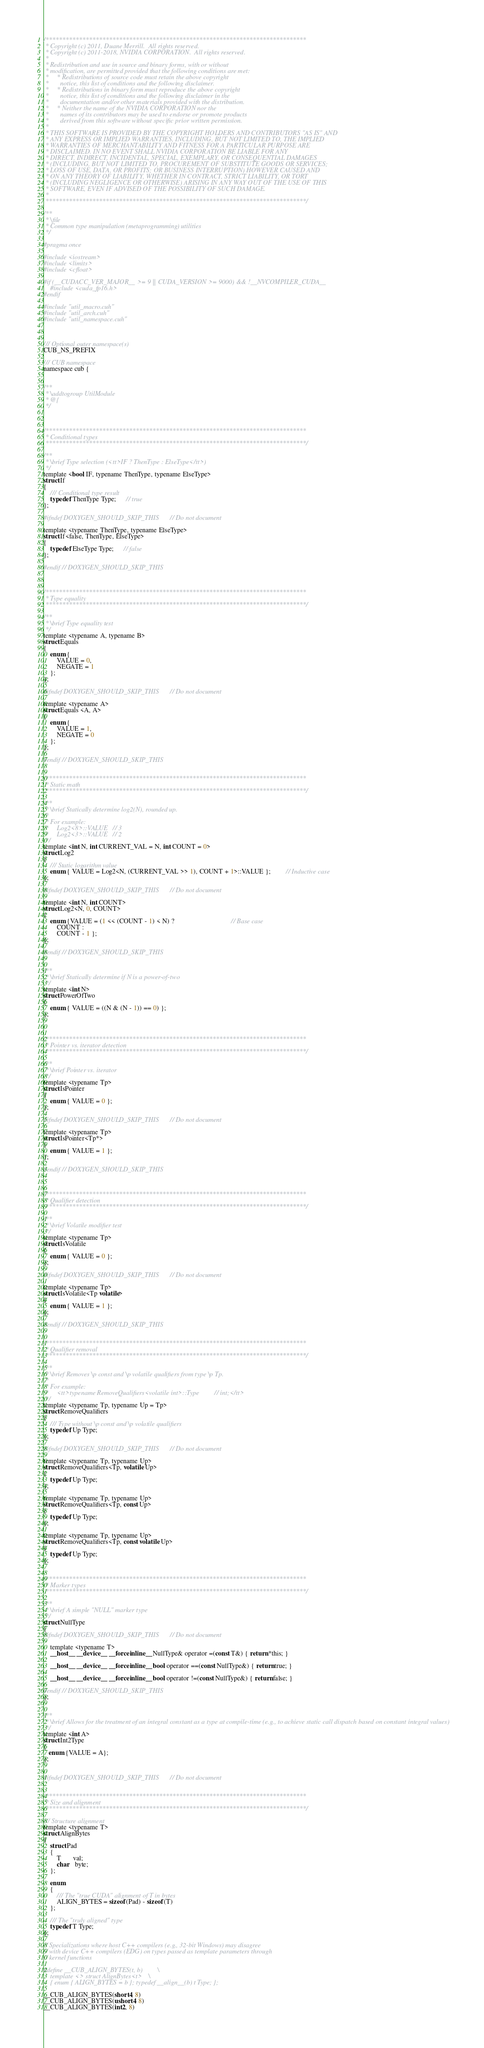<code> <loc_0><loc_0><loc_500><loc_500><_Cuda_>/******************************************************************************
 * Copyright (c) 2011, Duane Merrill.  All rights reserved.
 * Copyright (c) 2011-2018, NVIDIA CORPORATION.  All rights reserved.
 * 
 * Redistribution and use in source and binary forms, with or without
 * modification, are permitted provided that the following conditions are met:
 *     * Redistributions of source code must retain the above copyright
 *       notice, this list of conditions and the following disclaimer.
 *     * Redistributions in binary form must reproduce the above copyright
 *       notice, this list of conditions and the following disclaimer in the
 *       documentation and/or other materials provided with the distribution.
 *     * Neither the name of the NVIDIA CORPORATION nor the
 *       names of its contributors may be used to endorse or promote products
 *       derived from this software without specific prior written permission.
 * 
 * THIS SOFTWARE IS PROVIDED BY THE COPYRIGHT HOLDERS AND CONTRIBUTORS "AS IS" AND
 * ANY EXPRESS OR IMPLIED WARRANTIES, INCLUDING, BUT NOT LIMITED TO, THE IMPLIED
 * WARRANTIES OF MERCHANTABILITY AND FITNESS FOR A PARTICULAR PURPOSE ARE
 * DISCLAIMED. IN NO EVENT SHALL NVIDIA CORPORATION BE LIABLE FOR ANY
 * DIRECT, INDIRECT, INCIDENTAL, SPECIAL, EXEMPLARY, OR CONSEQUENTIAL DAMAGES
 * (INCLUDING, BUT NOT LIMITED TO, PROCUREMENT OF SUBSTITUTE GOODS OR SERVICES;
 * LOSS OF USE, DATA, OR PROFITS; OR BUSINESS INTERRUPTION) HOWEVER CAUSED AND
 * ON ANY THEORY OF LIABILITY, WHETHER IN CONTRACT, STRICT LIABILITY, OR TORT
 * (INCLUDING NEGLIGENCE OR OTHERWISE) ARISING IN ANY WAY OUT OF THE USE OF THIS
 * SOFTWARE, EVEN IF ADVISED OF THE POSSIBILITY OF SUCH DAMAGE.
 *
 ******************************************************************************/

/**
 * \file
 * Common type manipulation (metaprogramming) utilities
 */

#pragma once

#include <iostream>
#include <limits>
#include <cfloat>

#if (__CUDACC_VER_MAJOR__ >= 9 || CUDA_VERSION >= 9000) && !__NVCOMPILER_CUDA__
    #include <cuda_fp16.h>
#endif

#include "util_macro.cuh"
#include "util_arch.cuh"
#include "util_namespace.cuh"



/// Optional outer namespace(s)
CUB_NS_PREFIX

/// CUB namespace
namespace cub {


/**
 * \addtogroup UtilModule
 * @{
 */



/******************************************************************************
 * Conditional types
 ******************************************************************************/

/**
 * \brief Type selection (<tt>IF ? ThenType : ElseType</tt>)
 */
template <bool IF, typename ThenType, typename ElseType>
struct If
{
    /// Conditional type result
    typedef ThenType Type;      // true
};

#ifndef DOXYGEN_SHOULD_SKIP_THIS    // Do not document

template <typename ThenType, typename ElseType>
struct If<false, ThenType, ElseType>
{
    typedef ElseType Type;      // false
};

#endif // DOXYGEN_SHOULD_SKIP_THIS



/******************************************************************************
 * Type equality
 ******************************************************************************/

/**
 * \brief Type equality test
 */
template <typename A, typename B>
struct Equals
{
    enum {
        VALUE = 0,
        NEGATE = 1
    };
};

#ifndef DOXYGEN_SHOULD_SKIP_THIS    // Do not document

template <typename A>
struct Equals <A, A>
{
    enum {
        VALUE = 1,
        NEGATE = 0
    };
};

#endif // DOXYGEN_SHOULD_SKIP_THIS


/******************************************************************************
 * Static math
 ******************************************************************************/

/**
 * \brief Statically determine log2(N), rounded up.
 *
 * For example:
 *     Log2<8>::VALUE   // 3
 *     Log2<3>::VALUE   // 2
 */
template <int N, int CURRENT_VAL = N, int COUNT = 0>
struct Log2
{
    /// Static logarithm value
    enum { VALUE = Log2<N, (CURRENT_VAL >> 1), COUNT + 1>::VALUE };         // Inductive case
};

#ifndef DOXYGEN_SHOULD_SKIP_THIS    // Do not document

template <int N, int COUNT>
struct Log2<N, 0, COUNT>
{
    enum {VALUE = (1 << (COUNT - 1) < N) ?                                  // Base case
        COUNT :
        COUNT - 1 };
};

#endif // DOXYGEN_SHOULD_SKIP_THIS


/**
 * \brief Statically determine if N is a power-of-two
 */
template <int N>
struct PowerOfTwo
{
    enum { VALUE = ((N & (N - 1)) == 0) };
};



/******************************************************************************
 * Pointer vs. iterator detection
 ******************************************************************************/

/**
 * \brief Pointer vs. iterator
 */
template <typename Tp>
struct IsPointer
{
    enum { VALUE = 0 };
};

#ifndef DOXYGEN_SHOULD_SKIP_THIS    // Do not document

template <typename Tp>
struct IsPointer<Tp*>
{
    enum { VALUE = 1 };
};

#endif // DOXYGEN_SHOULD_SKIP_THIS



/******************************************************************************
 * Qualifier detection
 ******************************************************************************/

/**
 * \brief Volatile modifier test
 */
template <typename Tp>
struct IsVolatile
{
    enum { VALUE = 0 };
};

#ifndef DOXYGEN_SHOULD_SKIP_THIS    // Do not document

template <typename Tp>
struct IsVolatile<Tp volatile>
{
    enum { VALUE = 1 };
};

#endif // DOXYGEN_SHOULD_SKIP_THIS


/******************************************************************************
 * Qualifier removal
 ******************************************************************************/

/**
 * \brief Removes \p const and \p volatile qualifiers from type \p Tp.
 *
 * For example:
 *     <tt>typename RemoveQualifiers<volatile int>::Type         // int;</tt>
 */
template <typename Tp, typename Up = Tp>
struct RemoveQualifiers
{
    /// Type without \p const and \p volatile qualifiers
    typedef Up Type;
};

#ifndef DOXYGEN_SHOULD_SKIP_THIS    // Do not document

template <typename Tp, typename Up>
struct RemoveQualifiers<Tp, volatile Up>
{
    typedef Up Type;
};

template <typename Tp, typename Up>
struct RemoveQualifiers<Tp, const Up>
{
    typedef Up Type;
};

template <typename Tp, typename Up>
struct RemoveQualifiers<Tp, const volatile Up>
{
    typedef Up Type;
};


/******************************************************************************
 * Marker types
 ******************************************************************************/

/**
 * \brief A simple "NULL" marker type
 */
struct NullType
{
#ifndef DOXYGEN_SHOULD_SKIP_THIS    // Do not document

    template <typename T>
    __host__ __device__ __forceinline__ NullType& operator =(const T&) { return *this; }

    __host__ __device__ __forceinline__ bool operator ==(const NullType&) { return true; }

    __host__ __device__ __forceinline__ bool operator !=(const NullType&) { return false; }

#endif // DOXYGEN_SHOULD_SKIP_THIS
};


/**
 * \brief Allows for the treatment of an integral constant as a type at compile-time (e.g., to achieve static call dispatch based on constant integral values)
 */
template <int A>
struct Int2Type
{
   enum {VALUE = A};
};


#ifndef DOXYGEN_SHOULD_SKIP_THIS    // Do not document


/******************************************************************************
 * Size and alignment
 ******************************************************************************/

/// Structure alignment
template <typename T>
struct AlignBytes
{
    struct Pad
    {
        T       val;
        char    byte;
    };

    enum
    {
        /// The "true CUDA" alignment of T in bytes
        ALIGN_BYTES = sizeof(Pad) - sizeof(T)
    };

    /// The "truly aligned" type
    typedef T Type;
};

// Specializations where host C++ compilers (e.g., 32-bit Windows) may disagree
// with device C++ compilers (EDG) on types passed as template parameters through
// kernel functions

#define __CUB_ALIGN_BYTES(t, b)         \
    template <> struct AlignBytes<t>    \
    { enum { ALIGN_BYTES = b }; typedef __align__(b) t Type; };

__CUB_ALIGN_BYTES(short4, 8)
__CUB_ALIGN_BYTES(ushort4, 8)
__CUB_ALIGN_BYTES(int2, 8)</code> 